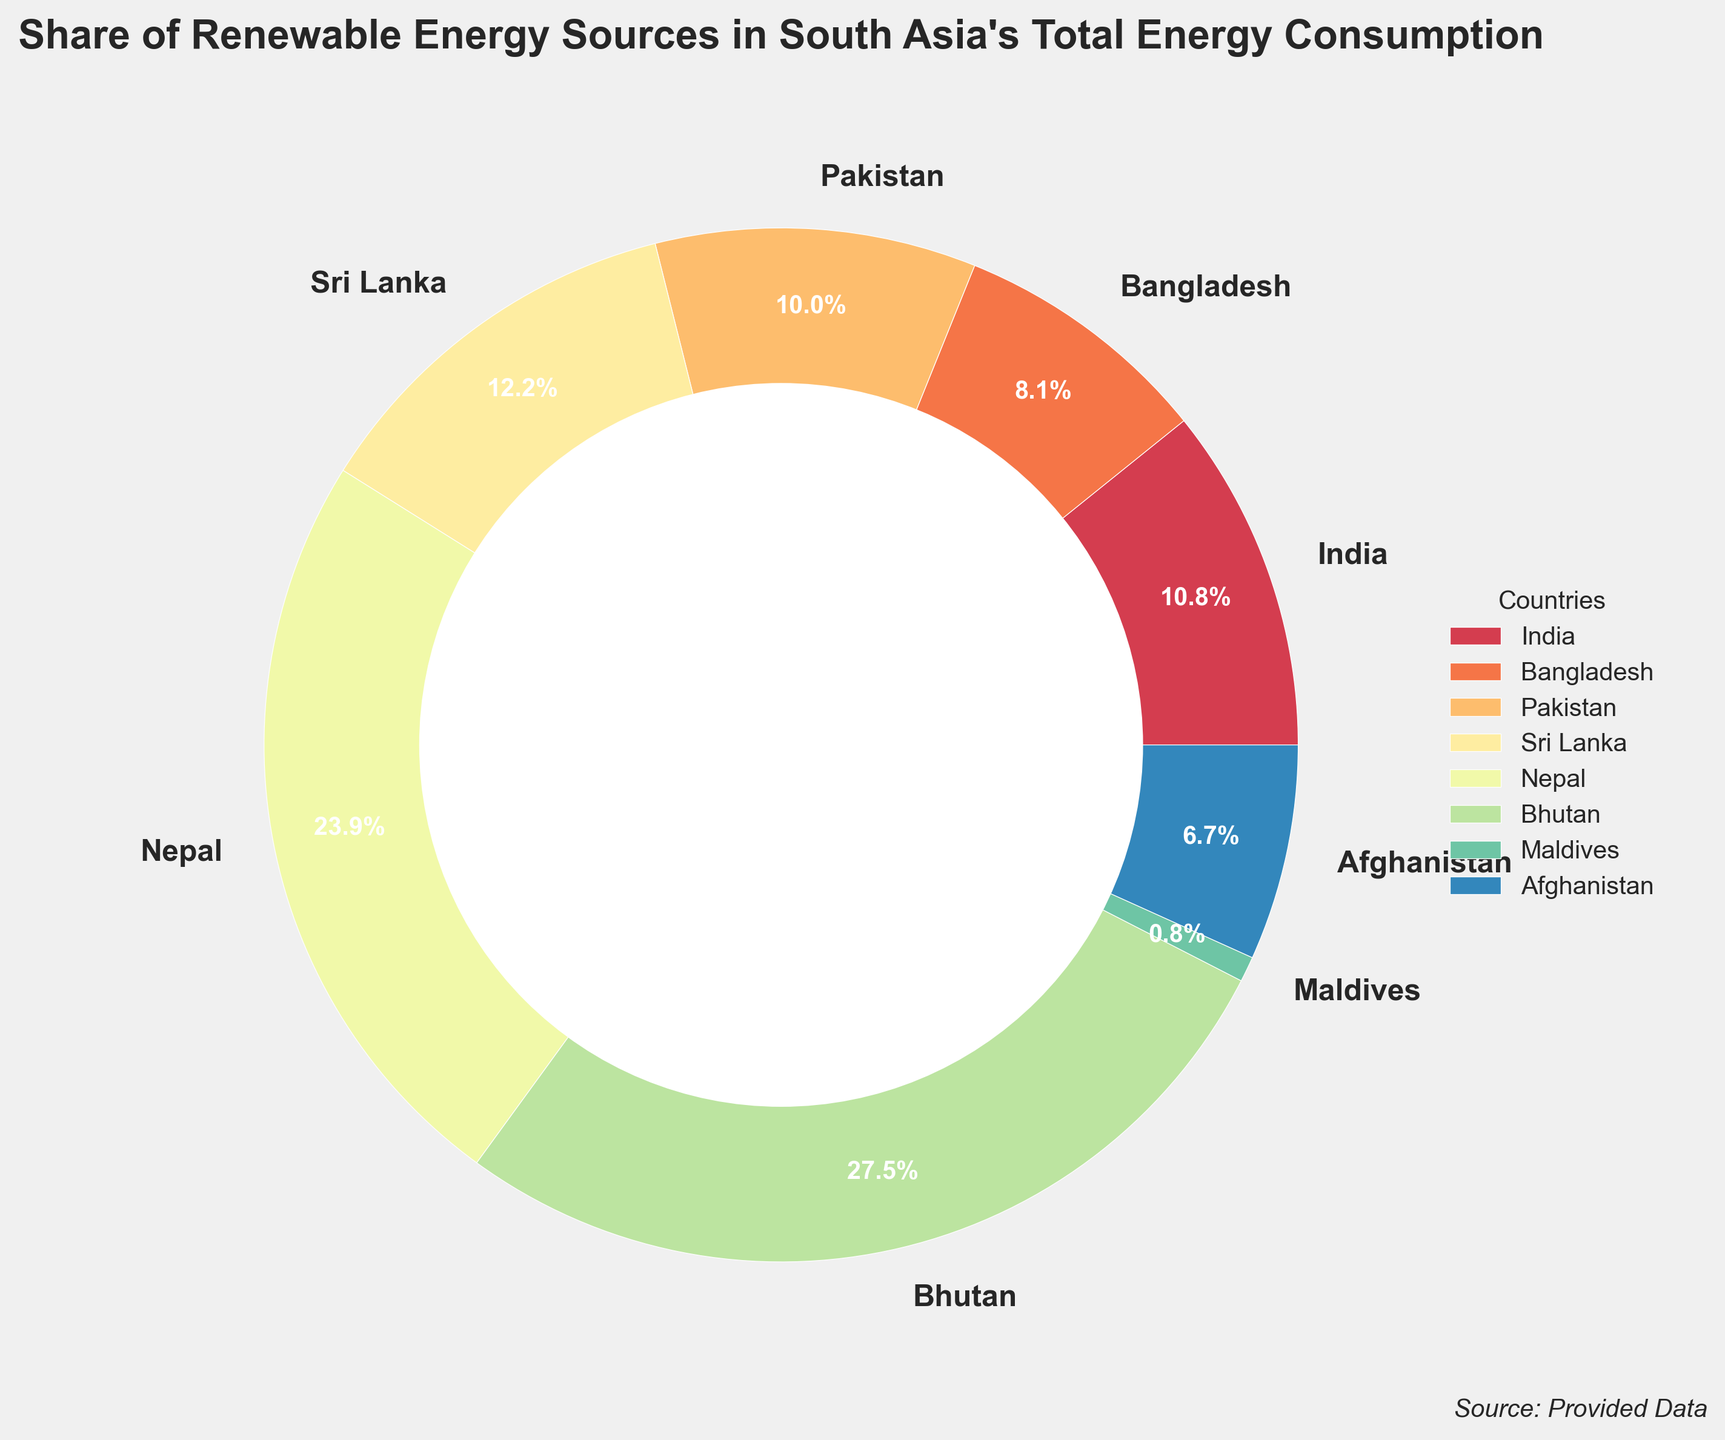Which country has the highest share of renewable energy? To determine the country with the highest share of renewable energy, look at the percentage labels on the pie chart and identify the maximum value. Bhutan has the highest share at 97.3%.
Answer: Bhutan Which two countries combined have a higher share of renewable energy than India alone? Add the shares of renewable energy for different combinations of countries and compare with India's share of 38.2%. Nepal (84.6%) and Maldives (2.8%) combined share (87.4%) is higher than India's share (38.2%).
Answer: Nepal and Maldives How much higher is Bhutan's share of renewable energy compared to Bangladesh? Subtract Bangladesh's share (28.7%) from Bhutan's share (97.3%). Calculation is 97.3% - 28.7% = 68.6%. Therefore, Bhutan's share is 68.6% higher than Bangladesh's.
Answer: 68.6% Which country has the lowest share of renewable energy, and what is its percentage? Identify the country with the smallest slice and check the label for the percentage. Maldives has the lowest share at 2.8%.
Answer: Maldives with 2.8% What is the average share of renewable energy among the listed South Asian countries? Sum the percentages of the renewable energy shares and divide by the number of countries. Calculation: (38.2 + 28.7 + 35.5 + 43.1 + 84.6 + 97.3 + 2.8 + 23.9) / 8 = 44.26%. The average share is 44.26%.
Answer: 44.26% Which countries have a share of renewable energy above the average share of 44.26%? Compare each country's share against the average (44.26%). Bhutan (97.3%) and Nepal (84.6%) are above the average.
Answer: Bhutan and Nepal How much larger is Sri Lanka's share of renewable energy compared to Afghanistan's? Subtract Afghanistan's share (23.9%) from Sri Lanka's share (43.1%). Calculation: 43.1% - 23.9% = 19.2%. Sri Lanka's share is 19.2% larger.
Answer: 19.2% If you combine the shares of Pakistan and Sri Lanka, do they add up to more or less than Nepal's share? Add Pakistan's share (35.5%) and Sri Lanka's share (43.1%) and compare with Nepal's share (84.6%). The combined share of Pakistan and Sri Lanka is 35.5% + 43.1% = 78.6%, which is less than Nepal's share (84.6%).
Answer: Less Which countries have a lower share of renewable energy than the regional average of 44.26%? Identify the countries with percentages less than 44.26%. India (38.2%), Bangladesh (28.7%), Pakistan (35.5%), Maldives (2.8%), and Afghanistan (23.9%) are below the regional average.
Answer: India, Bangladesh, Pakistan, Maldives, Afghanistan 